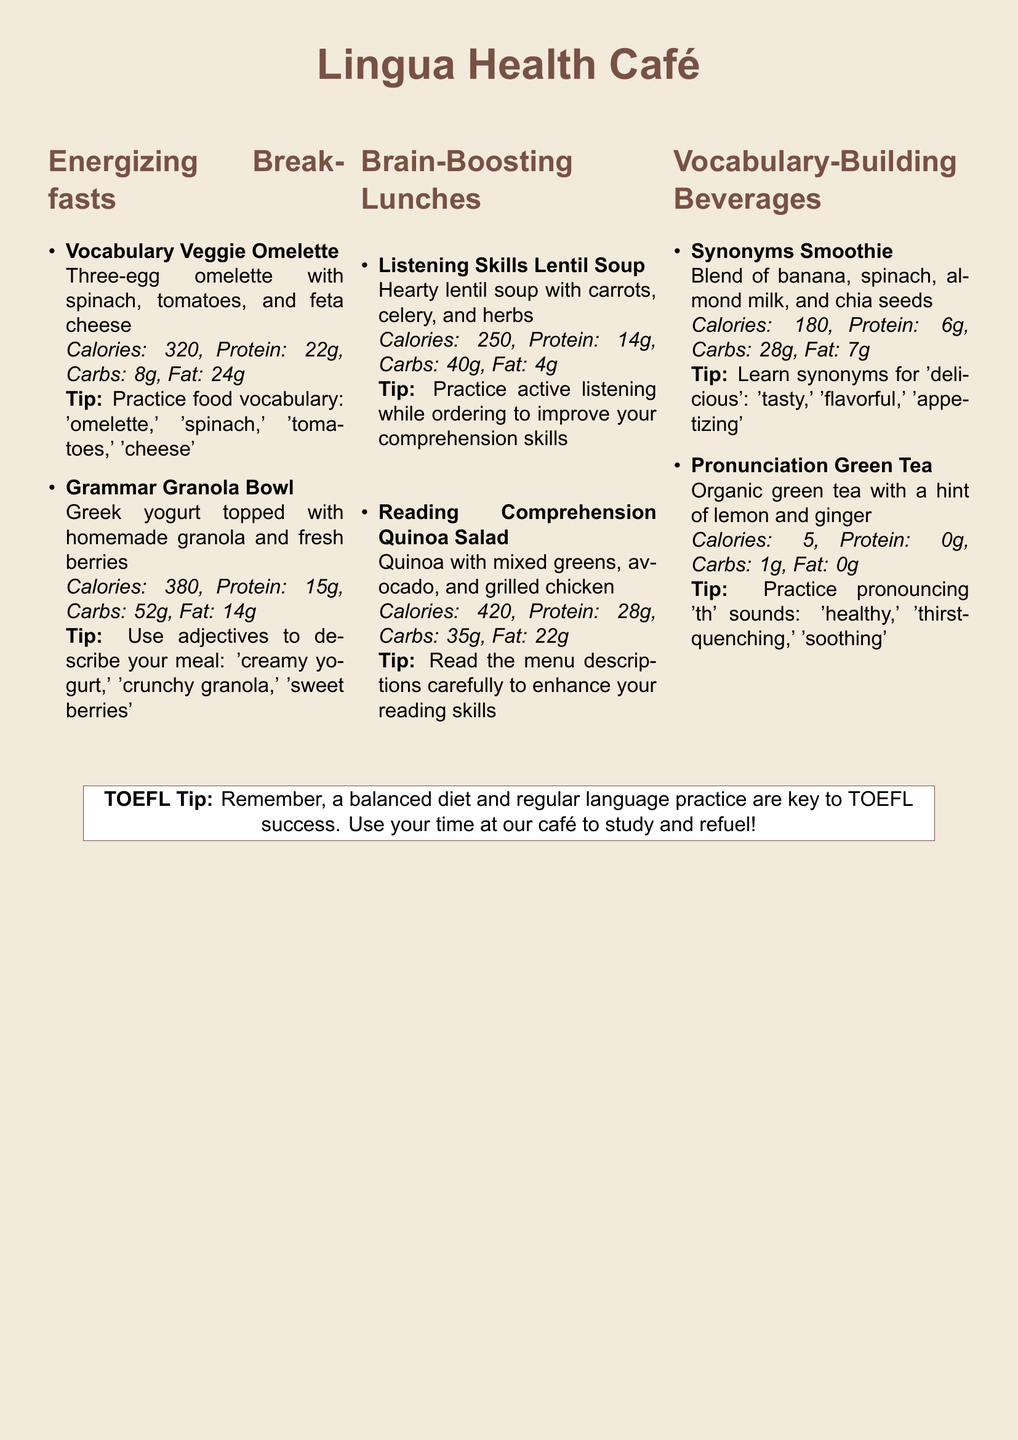What is the name of the café? The café is called "Lingua Health Café."
Answer: Lingua Health Café How many calories are in the Vocabulary Veggie Omelette? The document states that the Vocabulary Veggie Omelette has 320 calories.
Answer: 320 What protein content does the Grammar Granola Bowl have? The Grammar Granola Bowl contains 15 grams of protein as indicated in the nutritional information.
Answer: 15g What nutritional benefit does the Listening Skills Lentil Soup provide? The Listening Skills Lentil Soup has 14 grams of protein, indicating it provides a good source of protein.
Answer: 14g What type of beverage is the Synonyms Smoothie? The Synonyms Smoothie is a blend of banana, spinach, almond milk, and chia seeds as described in the menu.
Answer: Blend of banana, spinach, almond milk, and chia seeds Which meal is suggested for enhancing reading skills? The Reading Comprehension Quinoa Salad is suggested to enhance reading skills by reading the menu descriptions carefully.
Answer: Reading Comprehension Quinoa Salad What is the calorie count of the Pronunciation Green Tea? The Pronunciation Green Tea consists of 5 calories, according to the nutritional information provided.
Answer: 5 What tip is given for practicing while ordering food? The tip states to practice active listening while ordering to improve comprehension skills.
Answer: Practice active listening What should you remember for TOEFL success according to the café? The café suggests remembering that a balanced diet and regular language practice are key to TOEFL success.
Answer: A balanced diet and regular language practice 